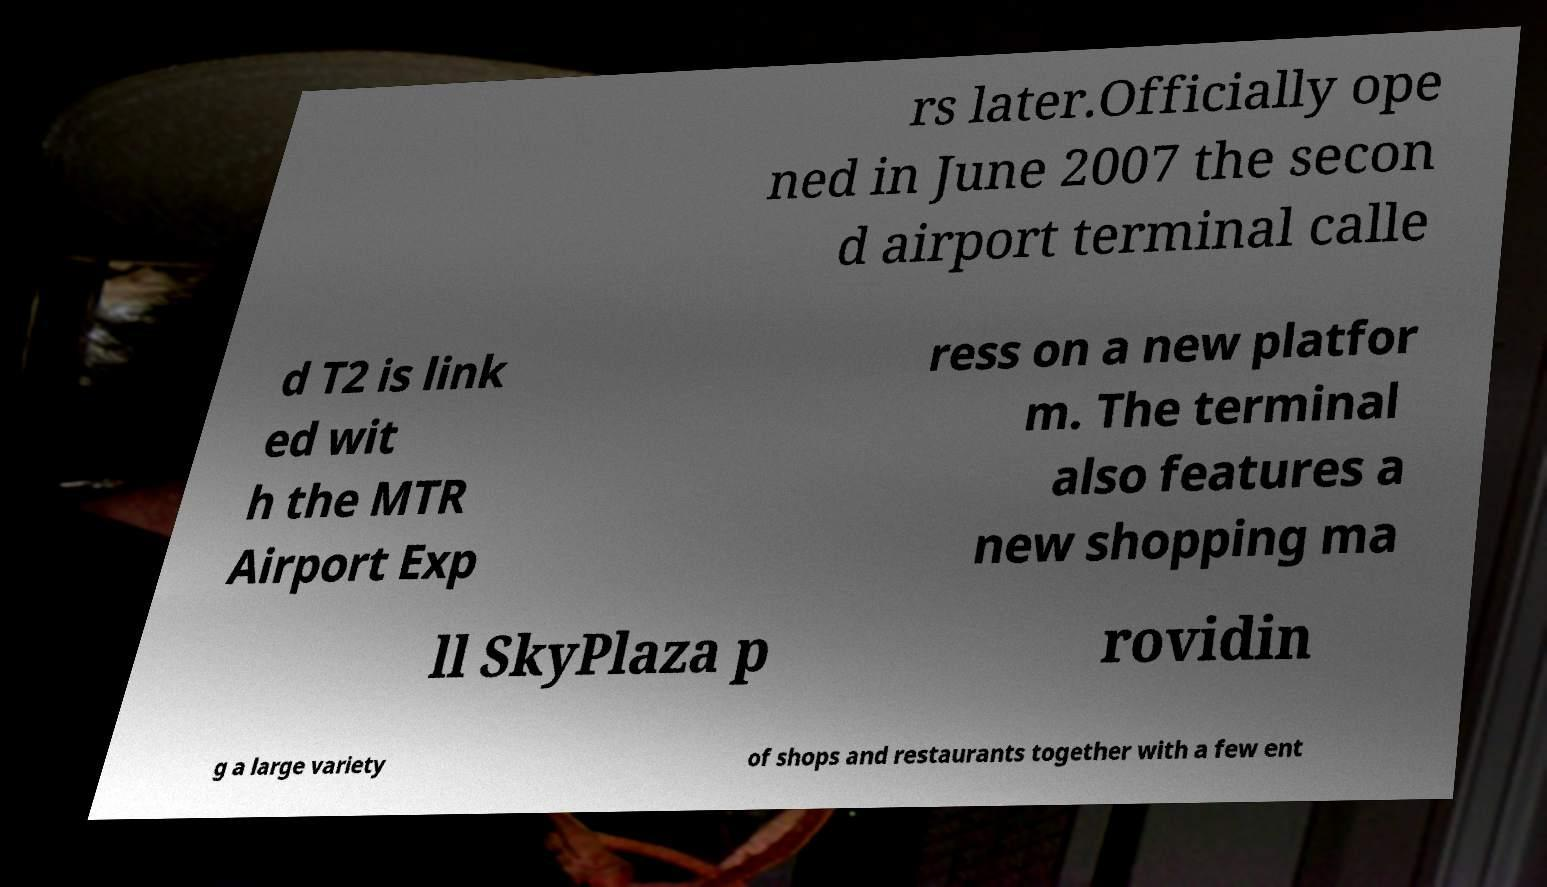What messages or text are displayed in this image? I need them in a readable, typed format. rs later.Officially ope ned in June 2007 the secon d airport terminal calle d T2 is link ed wit h the MTR Airport Exp ress on a new platfor m. The terminal also features a new shopping ma ll SkyPlaza p rovidin g a large variety of shops and restaurants together with a few ent 